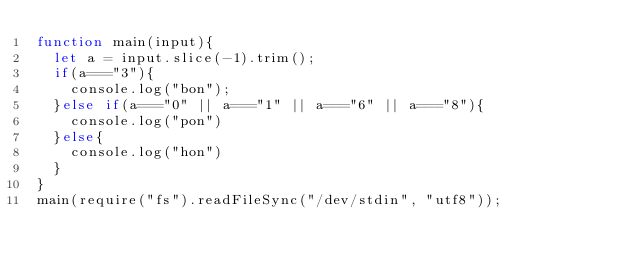<code> <loc_0><loc_0><loc_500><loc_500><_JavaScript_>function main(input){
  let a = input.slice(-1).trim();
  if(a==="3"){
    console.log("bon");
  }else if(a==="0" || a==="1" || a==="6" || a==="8"){
    console.log("pon")
  }else{
    console.log("hon")
  }
}
main(require("fs").readFileSync("/dev/stdin", "utf8"));</code> 